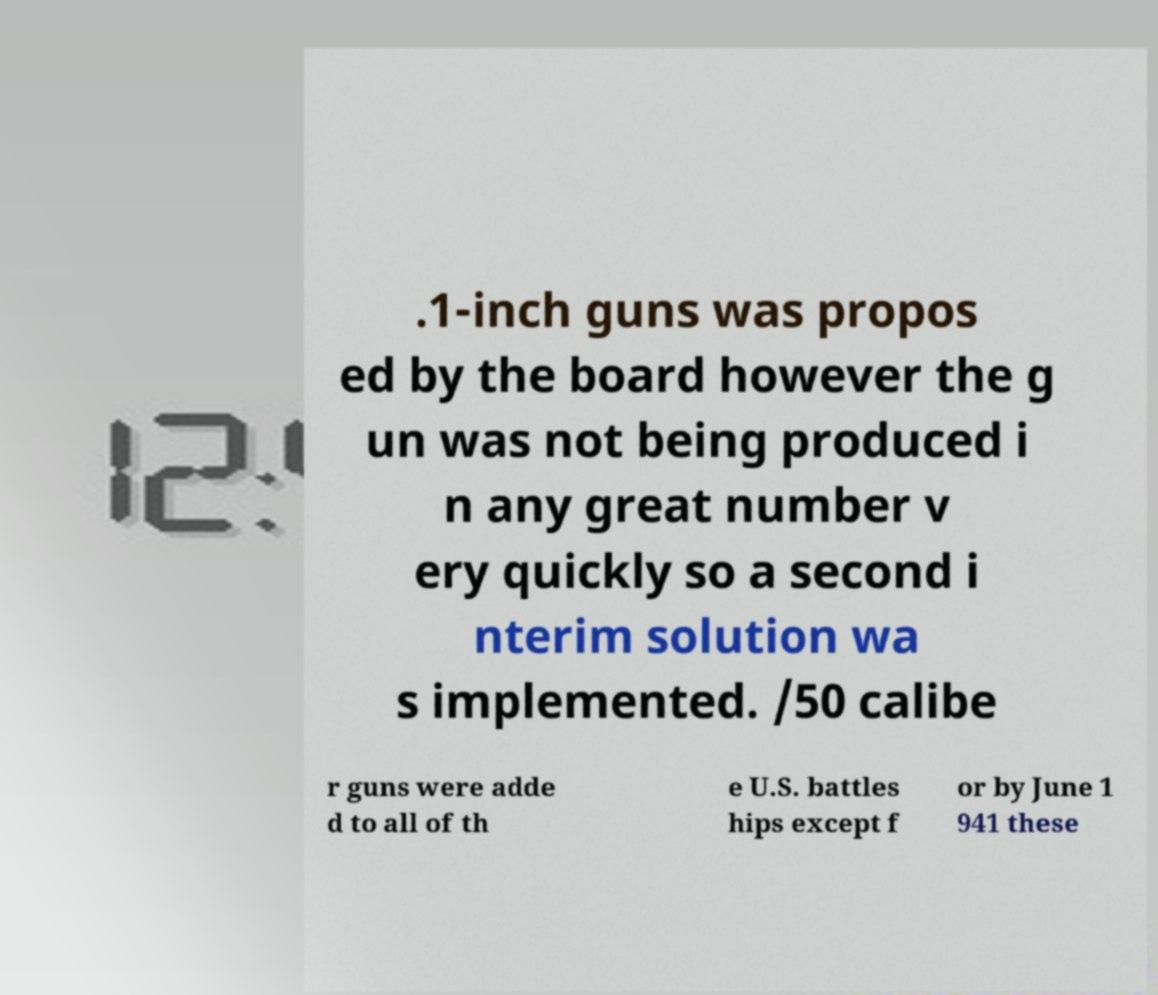For documentation purposes, I need the text within this image transcribed. Could you provide that? .1-inch guns was propos ed by the board however the g un was not being produced i n any great number v ery quickly so a second i nterim solution wa s implemented. /50 calibe r guns were adde d to all of th e U.S. battles hips except f or by June 1 941 these 